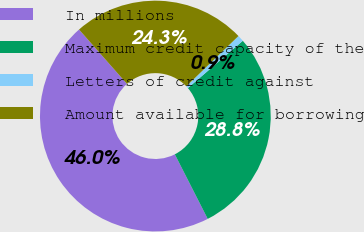<chart> <loc_0><loc_0><loc_500><loc_500><pie_chart><fcel>In millions<fcel>Maximum credit capacity of the<fcel>Letters of credit against<fcel>Amount available for borrowing<nl><fcel>45.99%<fcel>28.81%<fcel>0.89%<fcel>24.3%<nl></chart> 